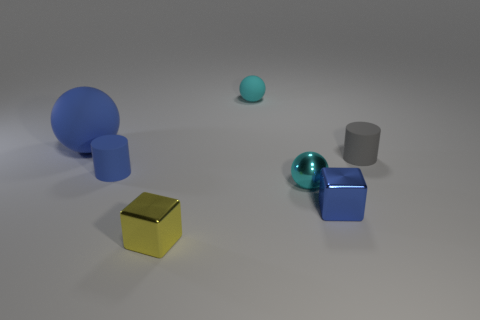Add 1 large blue metal objects. How many objects exist? 8 Subtract all blocks. How many objects are left? 5 Add 6 large blue matte objects. How many large blue matte objects are left? 7 Add 1 small yellow balls. How many small yellow balls exist? 1 Subtract 1 blue spheres. How many objects are left? 6 Subtract all large red metal blocks. Subtract all blue objects. How many objects are left? 4 